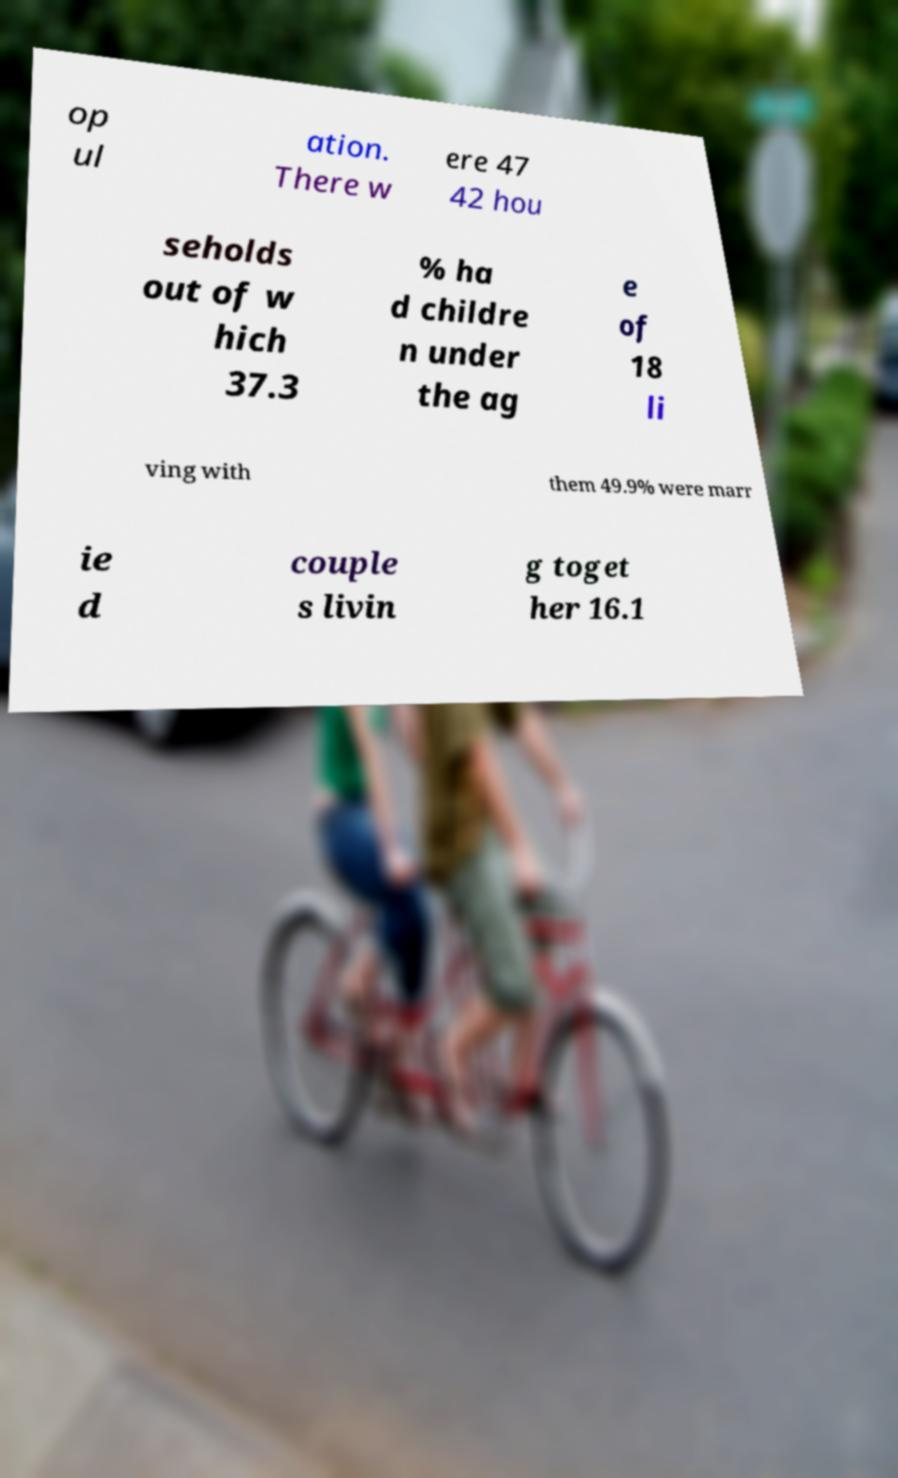Could you assist in decoding the text presented in this image and type it out clearly? op ul ation. There w ere 47 42 hou seholds out of w hich 37.3 % ha d childre n under the ag e of 18 li ving with them 49.9% were marr ie d couple s livin g toget her 16.1 